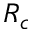<formula> <loc_0><loc_0><loc_500><loc_500>R _ { c }</formula> 